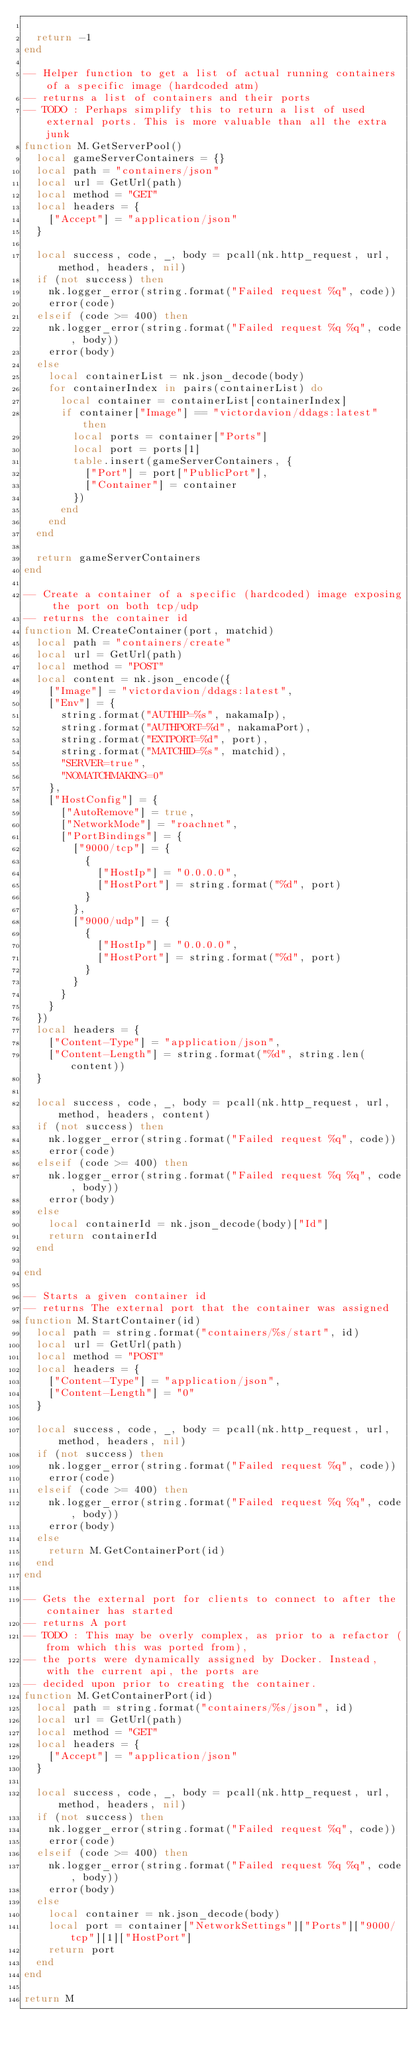<code> <loc_0><loc_0><loc_500><loc_500><_Lua_>	
	return -1
end

-- Helper function to get a list of actual running containers of a specific image (hardcoded atm)
-- returns a list of containers and their ports
-- TODO : Perhaps simplify this to return a list of used external ports. This is more valuable than all the extra junk
function M.GetServerPool()
	local gameServerContainers = {}
	local path = "containers/json"
	local url = GetUrl(path)
	local method = "GET"
	local headers = {
		["Accept"] = "application/json"
	}
	
	local success, code, _, body = pcall(nk.http_request, url, method, headers, nil)
	if (not success) then
		nk.logger_error(string.format("Failed request %q", code))
		error(code)
	elseif (code >= 400) then
		nk.logger_error(string.format("Failed request %q %q", code, body))
		error(body)
	else
		local containerList = nk.json_decode(body)
		for containerIndex in pairs(containerList) do
			local container = containerList[containerIndex]
			if container["Image"] == "victordavion/ddags:latest" then
				local ports = container["Ports"]
				local port = ports[1]
				table.insert(gameServerContainers, {
					["Port"] = port["PublicPort"],
					["Container"] = container
				})
			end
		end
	end
	
	return gameServerContainers
end

-- Create a container of a specific (hardcoded) image exposing the port on both tcp/udp
-- returns the container id
function M.CreateContainer(port, matchid)
	local path = "containers/create"
	local url = GetUrl(path)
	local method = "POST"
	local content = nk.json_encode({
		["Image"] = "victordavion/ddags:latest",
		["Env"] = {
			string.format("AUTHIP=%s", nakamaIp),
			string.format("AUTHPORT=%d", nakamaPort),
			string.format("EXTPORT=%d", port),
			string.format("MATCHID=%s", matchid),
			"SERVER=true",
			"NOMATCHMAKING=0"
		},
		["HostConfig"] = {
			["AutoRemove"] = true,
			["NetworkMode"] = "roachnet",
			["PortBindings"] = {
				["9000/tcp"] = {
					{
						["HostIp"] = "0.0.0.0",
						["HostPort"] = string.format("%d", port)
					}
				},
				["9000/udp"] = {
					{
						["HostIp"] = "0.0.0.0",
						["HostPort"] = string.format("%d", port)
					}
				}
			}
		}
	})
	local headers = {
		["Content-Type"] = "application/json",
		["Content-Length"] = string.format("%d", string.len(content))
	}
	
	local success, code, _, body = pcall(nk.http_request, url, method, headers, content)
	if (not success) then
		nk.logger_error(string.format("Failed request %q", code))
		error(code)
	elseif (code >= 400) then
		nk.logger_error(string.format("Failed request %q %q", code, body))
		error(body)
	else
		local containerId = nk.json_decode(body)["Id"]
		return containerId
	end
	
end

-- Starts a given container id
-- returns The external port that the container was assigned
function M.StartContainer(id)
	local path = string.format("containers/%s/start", id)
	local url = GetUrl(path)
	local method = "POST"
	local headers = {
		["Content-Type"] = "application/json",
		["Content-Length"] = "0"
	}
	
	local success, code, _, body = pcall(nk.http_request, url, method, headers, nil)
	if (not success) then
		nk.logger_error(string.format("Failed request %q", code))
		error(code)
	elseif (code >= 400) then
		nk.logger_error(string.format("Failed request %q %q", code, body))
		error(body)
	else
		return M.GetContainerPort(id)
	end
end

-- Gets the external port for clients to connect to after the container has started
-- returns A port
-- TODO : This may be overly complex, as prior to a refactor (from which this was ported from),
-- the ports were dynamically assigned by Docker. Instead, with the current api, the ports are
-- decided upon prior to creating the container.
function M.GetContainerPort(id)
	local path = string.format("containers/%s/json", id)
	local url = GetUrl(path)
	local method = "GET"
	local headers = {
		["Accept"] = "application/json"
	}
	
	local success, code, _, body = pcall(nk.http_request, url, method, headers, nil)
	if (not success) then
		nk.logger_error(string.format("Failed request %q", code))
		error(code)
	elseif (code >= 400) then
		nk.logger_error(string.format("Failed request %q %q", code, body))
		error(body)
	else
		local container = nk.json_decode(body)
		local port = container["NetworkSettings"]["Ports"]["9000/tcp"][1]["HostPort"]
		return port
	end
end

return M
</code> 